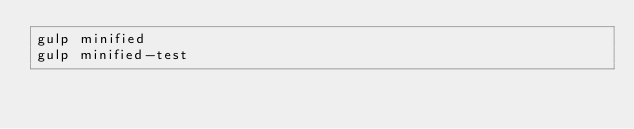<code> <loc_0><loc_0><loc_500><loc_500><_Bash_>gulp minified
gulp minified-test</code> 